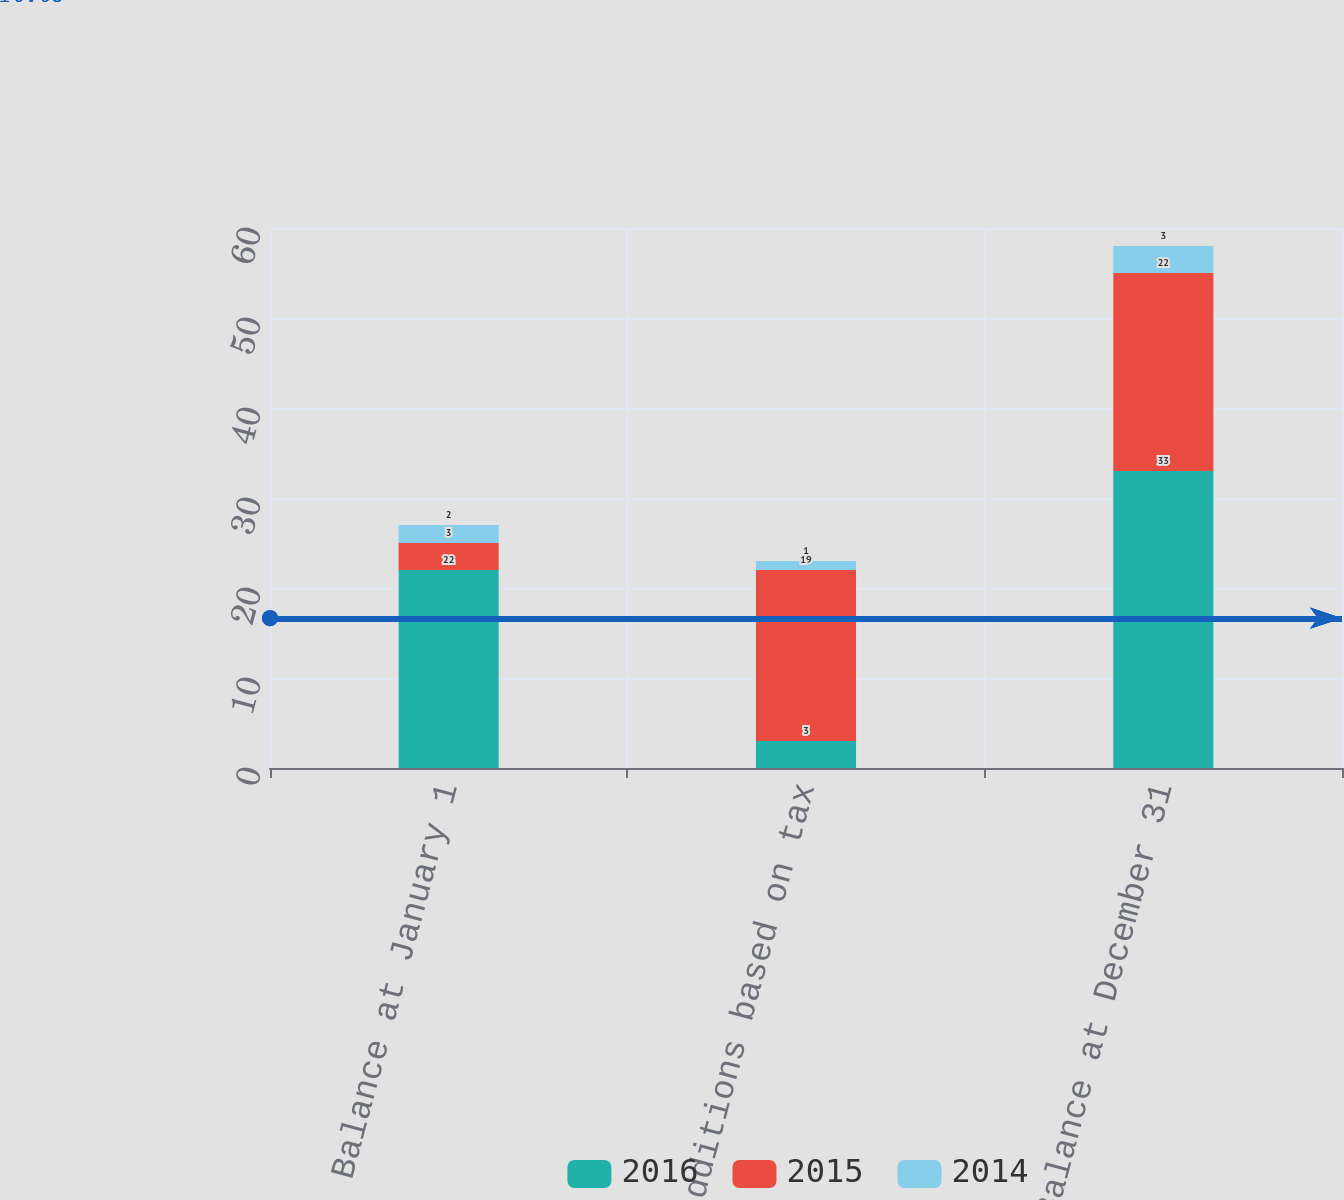Convert chart. <chart><loc_0><loc_0><loc_500><loc_500><stacked_bar_chart><ecel><fcel>Balance at January 1<fcel>Additions based on tax<fcel>Balance at December 31<nl><fcel>2016<fcel>22<fcel>3<fcel>33<nl><fcel>2015<fcel>3<fcel>19<fcel>22<nl><fcel>2014<fcel>2<fcel>1<fcel>3<nl></chart> 